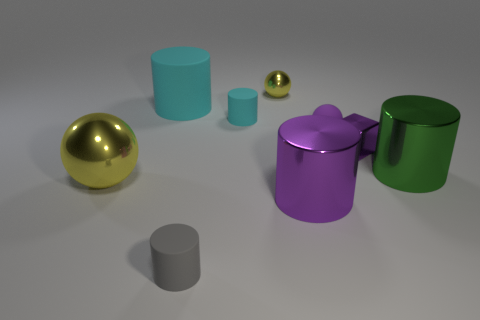What number of small balls are to the right of the tiny metallic thing that is behind the tiny cyan thing? To the right of the small metallic sphere, which is situated behind the cyan cylinder, there is a single small gold-colored ball. 